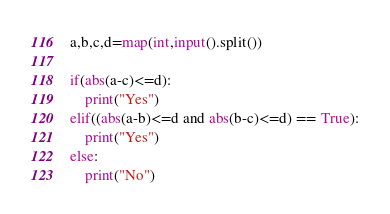Convert code to text. <code><loc_0><loc_0><loc_500><loc_500><_Python_>a,b,c,d=map(int,input().split())

if(abs(a-c)<=d):
	print("Yes")
elif((abs(a-b)<=d and abs(b-c)<=d) == True):
	print("Yes")
else:
	print("No")</code> 